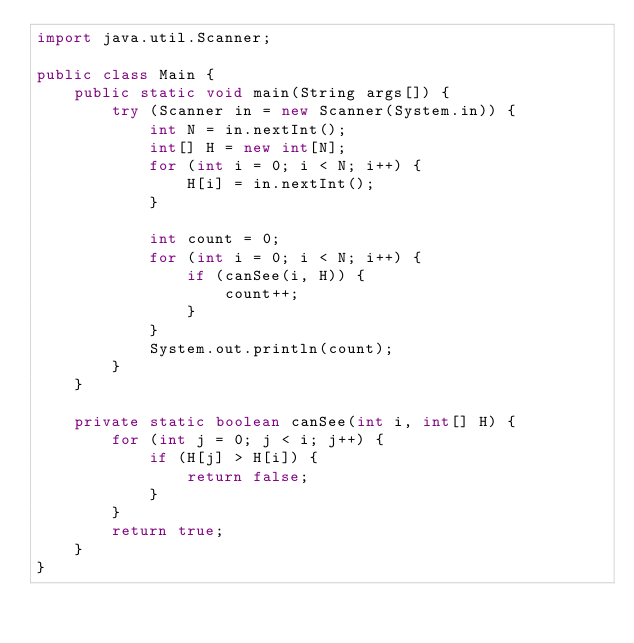<code> <loc_0><loc_0><loc_500><loc_500><_Java_>import java.util.Scanner;

public class Main {
    public static void main(String args[]) {
        try (Scanner in = new Scanner(System.in)) {
            int N = in.nextInt();
            int[] H = new int[N];
            for (int i = 0; i < N; i++) {
                H[i] = in.nextInt();
            }

            int count = 0;
            for (int i = 0; i < N; i++) {
                if (canSee(i, H)) {
                    count++;
                }
            }
            System.out.println(count);
        }
    }

    private static boolean canSee(int i, int[] H) {
        for (int j = 0; j < i; j++) {
            if (H[j] > H[i]) {
                return false;
            }
        }
        return true;
    }
}
</code> 